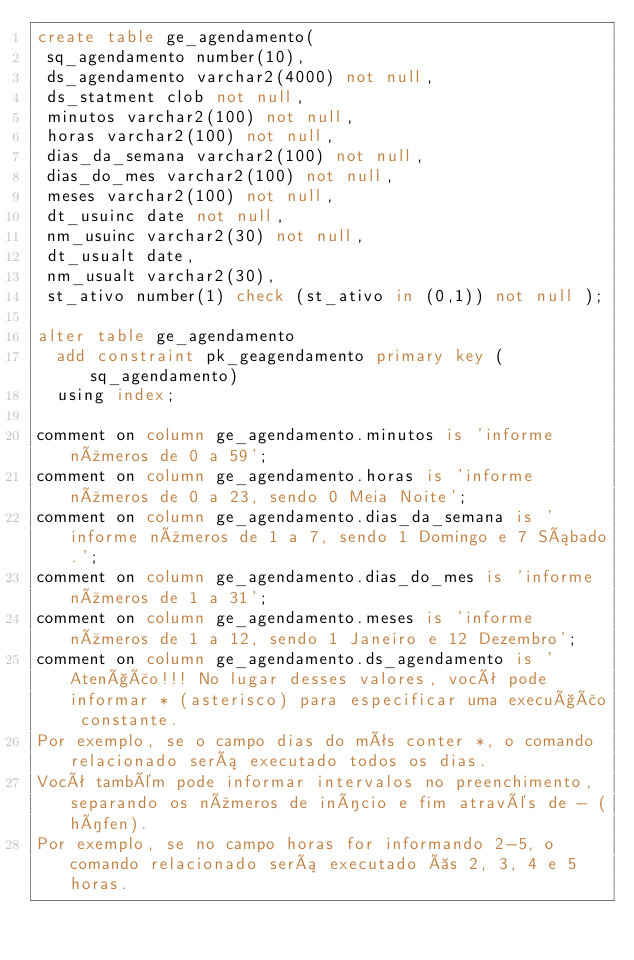<code> <loc_0><loc_0><loc_500><loc_500><_SQL_>create table ge_agendamento(
 sq_agendamento number(10),
 ds_agendamento varchar2(4000) not null,
 ds_statment clob not null,
 minutos varchar2(100) not null, 
 horas varchar2(100) not null,
 dias_da_semana varchar2(100) not null,
 dias_do_mes varchar2(100) not null,
 meses varchar2(100) not null,
 dt_usuinc date not null,
 nm_usuinc varchar2(30) not null,
 dt_usualt date,
 nm_usualt varchar2(30),
 st_ativo number(1) check (st_ativo in (0,1)) not null );  

alter table ge_agendamento
  add constraint pk_geagendamento primary key (sq_agendamento)
  using index;

comment on column ge_agendamento.minutos is 'informe números de 0 a 59';
comment on column ge_agendamento.horas is 'informe números de 0 a 23, sendo 0 Meia Noite';
comment on column ge_agendamento.dias_da_semana is 'informe números de 1 a 7, sendo 1 Domingo e 7 Sábado.';
comment on column ge_agendamento.dias_do_mes is 'informe números de 1 a 31';
comment on column ge_agendamento.meses is 'informe números de 1 a 12, sendo 1 Janeiro e 12 Dezembro';
comment on column ge_agendamento.ds_agendamento is 'Atenção!!! No lugar desses valores, você pode informar * (asterisco) para especificar uma execução constante. 
Por exemplo, se o campo dias do mês conter *, o comando relacionado será executado todos os dias. 
Você também pode informar intervalos no preenchimento, separando os números de início e fim através de - (hífen). 
Por exemplo, se no campo horas for informando 2-5, o comando relacionado será executado às 2, 3, 4 e 5 horas. </code> 